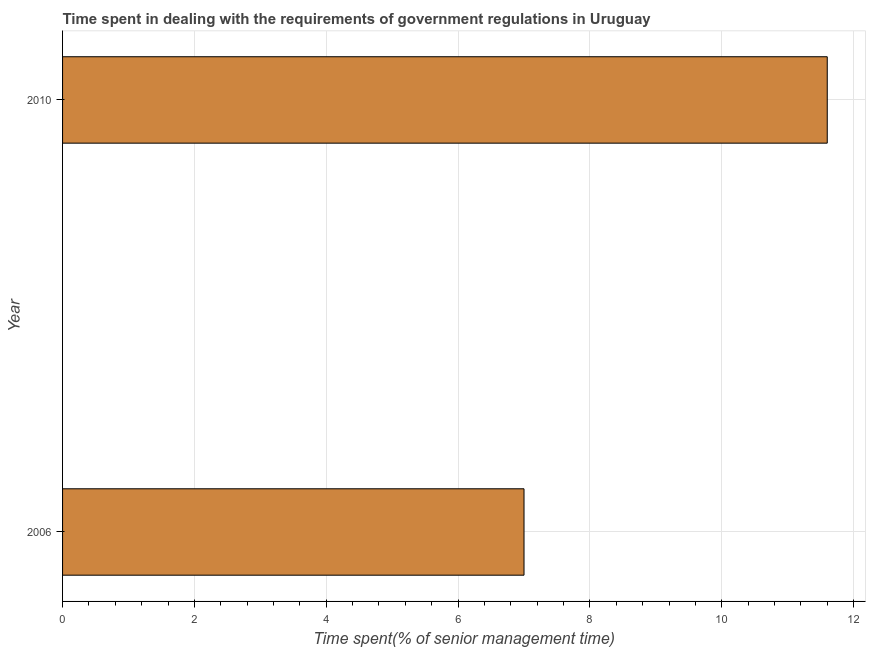Does the graph contain grids?
Give a very brief answer. Yes. What is the title of the graph?
Give a very brief answer. Time spent in dealing with the requirements of government regulations in Uruguay. What is the label or title of the X-axis?
Provide a succinct answer. Time spent(% of senior management time). What is the label or title of the Y-axis?
Give a very brief answer. Year. Across all years, what is the minimum time spent in dealing with government regulations?
Give a very brief answer. 7. In which year was the time spent in dealing with government regulations minimum?
Give a very brief answer. 2006. What is the sum of the time spent in dealing with government regulations?
Your answer should be compact. 18.6. What is the median time spent in dealing with government regulations?
Give a very brief answer. 9.3. In how many years, is the time spent in dealing with government regulations greater than 4.8 %?
Give a very brief answer. 2. What is the ratio of the time spent in dealing with government regulations in 2006 to that in 2010?
Offer a terse response. 0.6. In how many years, is the time spent in dealing with government regulations greater than the average time spent in dealing with government regulations taken over all years?
Offer a very short reply. 1. Are all the bars in the graph horizontal?
Your answer should be compact. Yes. Are the values on the major ticks of X-axis written in scientific E-notation?
Keep it short and to the point. No. What is the Time spent(% of senior management time) in 2006?
Provide a succinct answer. 7. What is the ratio of the Time spent(% of senior management time) in 2006 to that in 2010?
Your answer should be very brief. 0.6. 